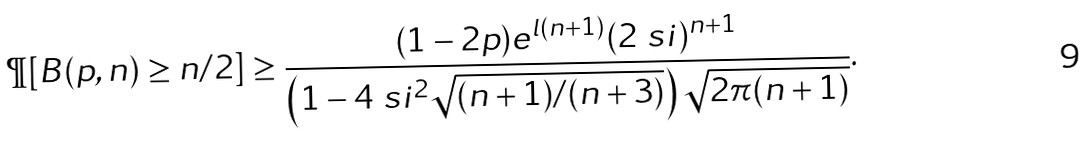<formula> <loc_0><loc_0><loc_500><loc_500>\P [ B ( p , n ) \geq n / 2 ] \geq \frac { ( 1 - 2 p ) e ^ { l ( n + 1 ) } ( 2 \ s i ) ^ { n + 1 } } { \left ( 1 - 4 \ s i ^ { 2 } \sqrt { ( n + 1 ) / ( n + 3 ) } \right ) \sqrt { 2 \pi ( n + 1 ) } } .</formula> 